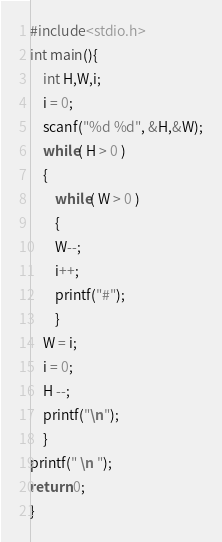<code> <loc_0><loc_0><loc_500><loc_500><_C_>#include<stdio.h>
int main(){
	int H,W,i;
	i = 0;
	scanf("%d %d", &H,&W);
	while( H > 0 )
	{
		while( W > 0 )
		{
		W--;
		i++;
		printf("#");
		}
	W = i;
	i = 0;
	H --;
	printf("\n");
	}
printf(" \n ");
return 0;
}


</code> 